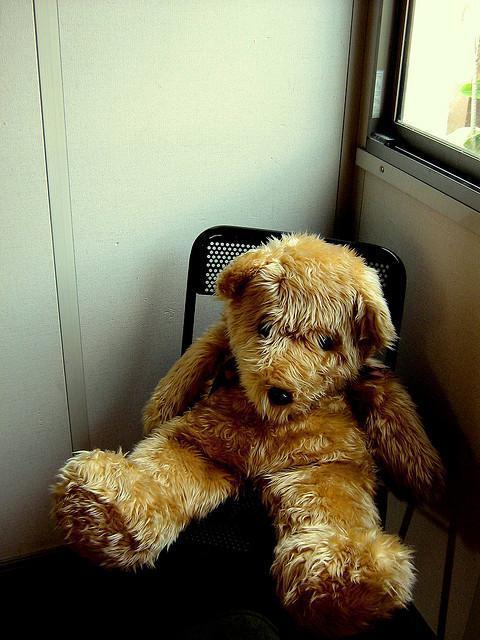How many boats are there in the picture?
Give a very brief answer. 0. 